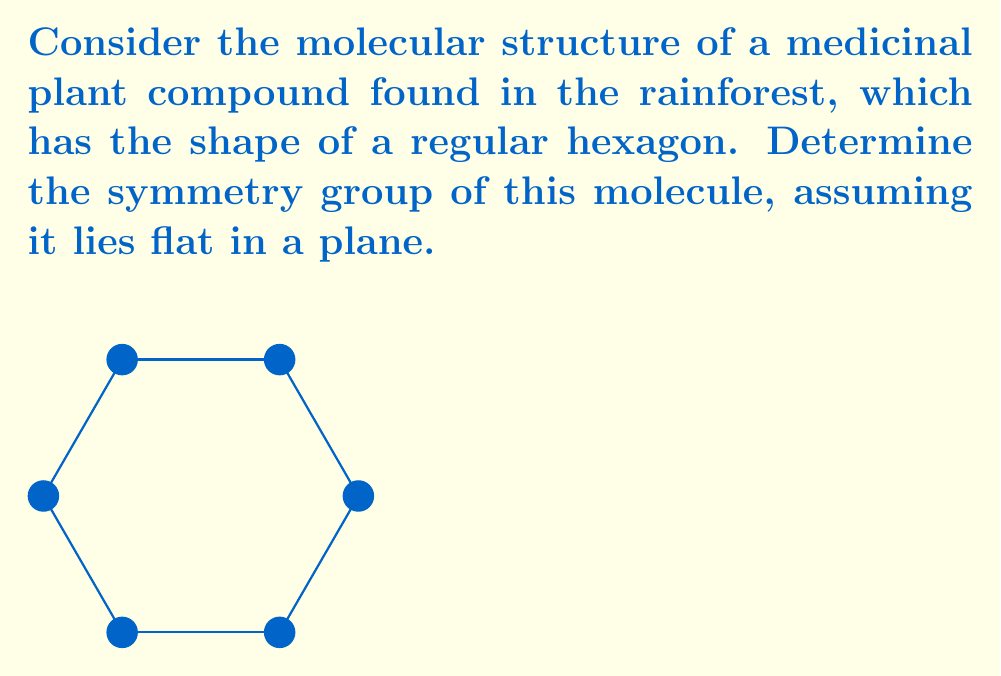Solve this math problem. To determine the symmetry group of this molecular structure, we need to identify all the symmetry operations that leave the hexagon unchanged. Let's proceed step-by-step:

1) Rotational symmetries:
   The hexagon has 6-fold rotational symmetry. It can be rotated by multiples of 60° (or $\frac{\pi}{3}$ radians) and remain unchanged.
   Rotations: 0°, 60°, 120°, 180°, 240°, 300°

2) Reflection symmetries:
   The hexagon has 6 lines of reflection symmetry:
   - 3 passing through opposite vertices
   - 3 passing through the midpoints of opposite sides

3) Identity transformation:
   The identity transformation (doing nothing) is always a symmetry.

These symmetries form a group under composition. This group is known as the dihedral group of order 12, denoted as $D_6$ or $D_{12}$.

The group has the following properties:
- Order of the group: 12 (6 rotations + 6 reflections)
- Generators: $r$ (rotation by 60°) and $s$ (any reflection)
- Presentation: $D_6 = \langle r,s | r^6=s^2=1, srs=r^{-1} \rangle$

The elements of $D_6$ can be written as:
$$D_6 = \{1, r, r^2, r^3, r^4, r^5, s, sr, sr^2, sr^3, sr^4, sr^5\}$$

where $r^k$ represents a rotation by $60k$ degrees, and $sr^k$ represents a reflection followed by a rotation.
Answer: $D_6$ (dihedral group of order 12) 